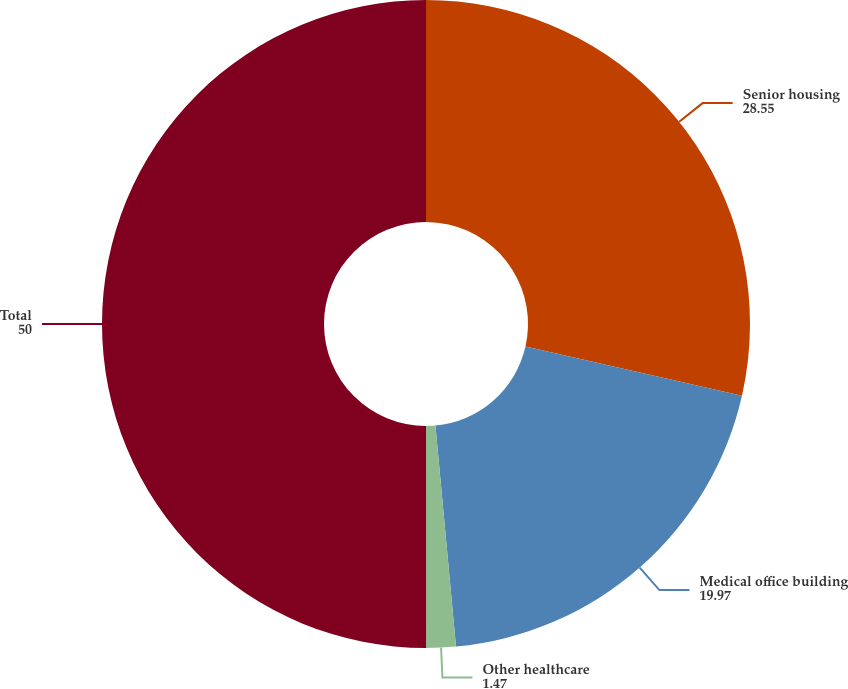Convert chart to OTSL. <chart><loc_0><loc_0><loc_500><loc_500><pie_chart><fcel>Senior housing<fcel>Medical office building<fcel>Other healthcare<fcel>Total<nl><fcel>28.55%<fcel>19.97%<fcel>1.47%<fcel>50.0%<nl></chart> 